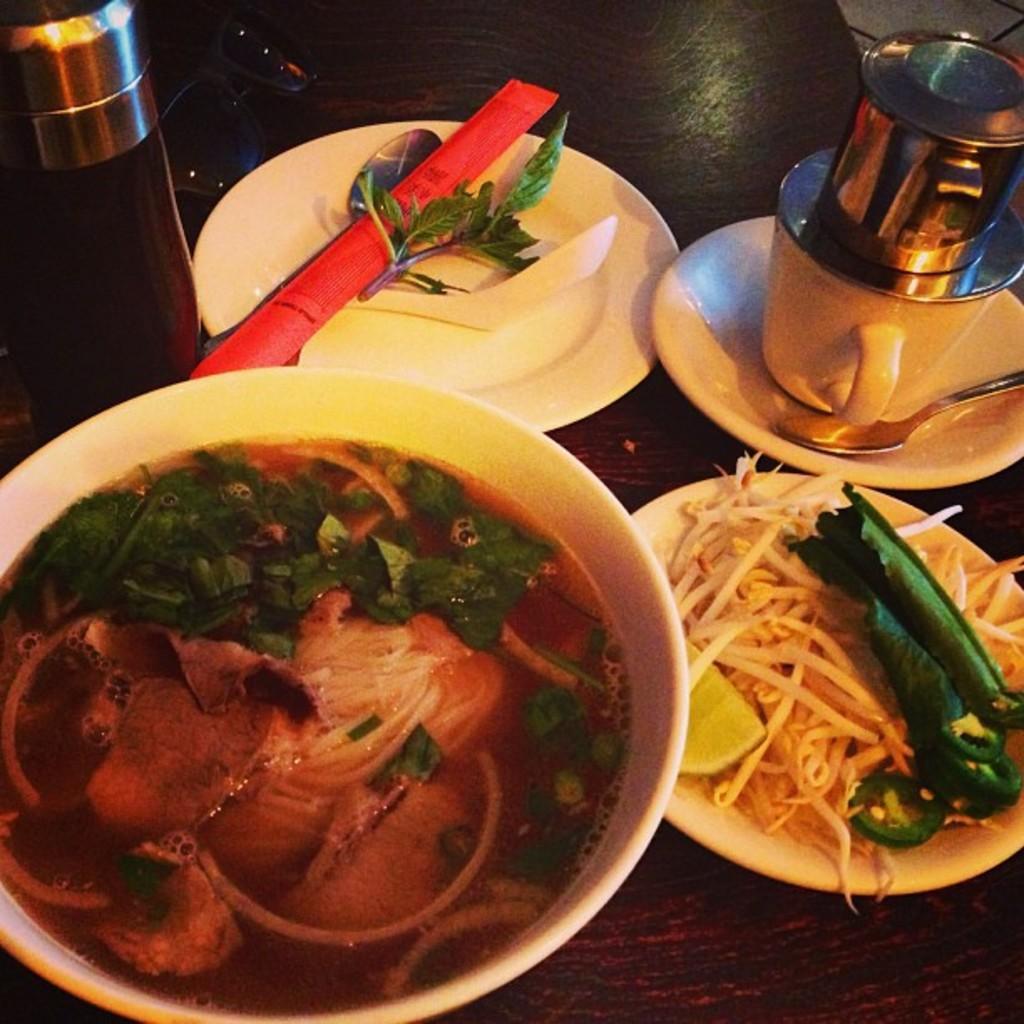Can you describe this image briefly? In this image there is a table truncated, there are objects on the table, there is a bowl truncated towards the left of the image, there is food in the bowl, there is a plate truncated towards the right of the image, there is food on the plate, there is a saucer truncated towards the right of the image, there is a spoon truncated towards the right of the image, there is a cup, there is a plate, there are objects on the plate, there is an object truncated towards the top of the image, there is an object truncated towards the right of the image. 